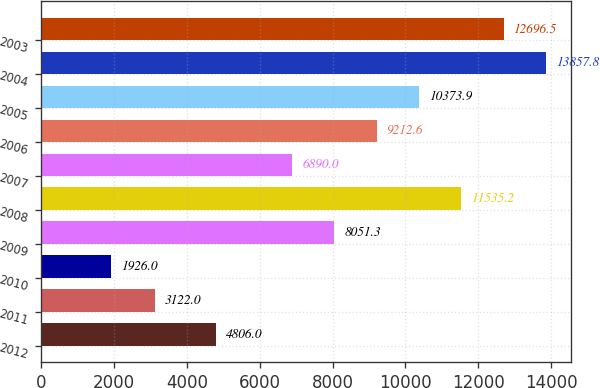<chart> <loc_0><loc_0><loc_500><loc_500><bar_chart><fcel>2012<fcel>2011<fcel>2010<fcel>2009<fcel>2008<fcel>2007<fcel>2006<fcel>2005<fcel>2004<fcel>2003<nl><fcel>4806<fcel>3122<fcel>1926<fcel>8051.3<fcel>11535.2<fcel>6890<fcel>9212.6<fcel>10373.9<fcel>13857.8<fcel>12696.5<nl></chart> 